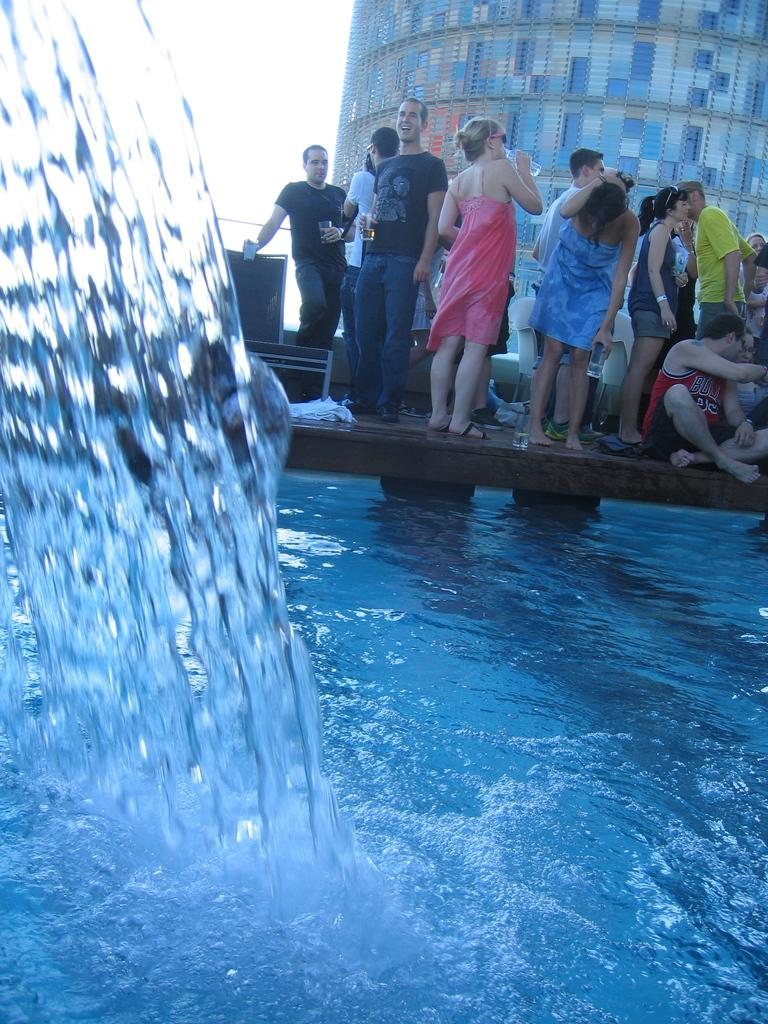What is in the foreground of the image? There is water in the foreground of the image. What is located behind the water? There is a bridge behind the water. Are there any people in the image? Yes, there are people on the bridge. What type of music can be heard coming from the frame in the image? There is no frame or music present in the image; it features water and a bridge with people on it. 